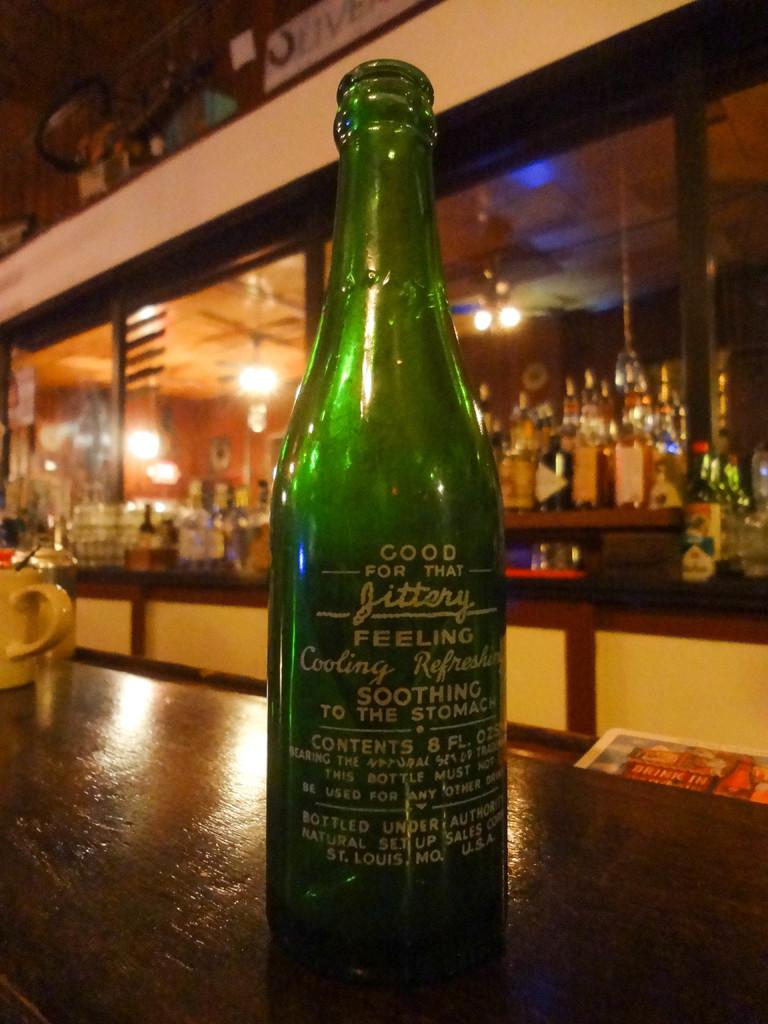What is this drink good for ?
Ensure brevity in your answer.  Jittery feeling. Where was this bottled?
Offer a very short reply. St louis. 